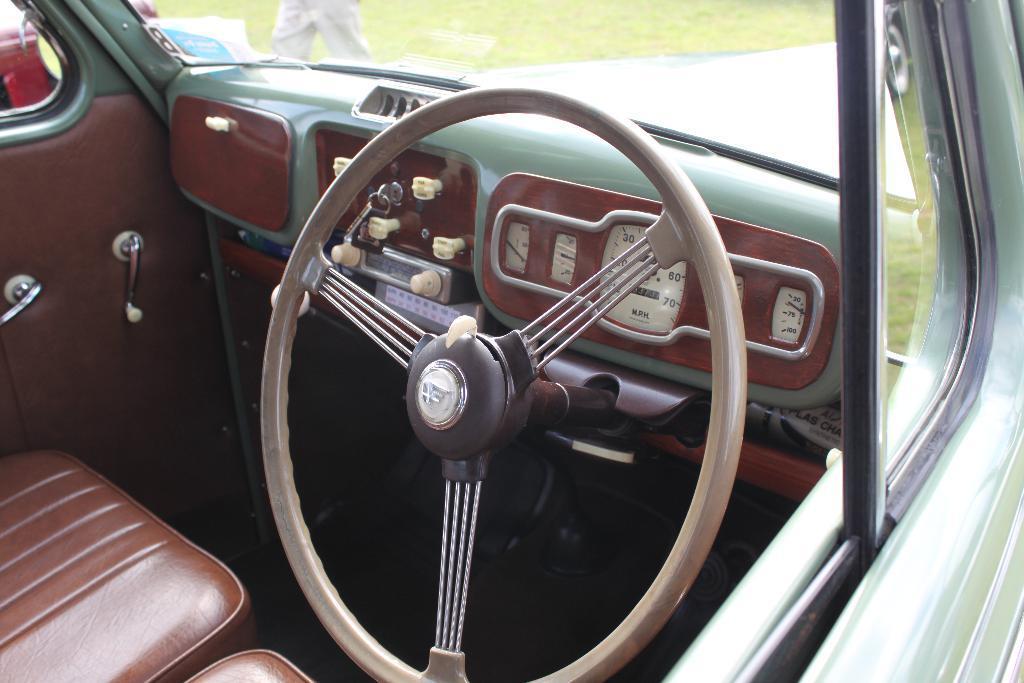Can you describe this image briefly? This picture is taken inside the vehicle. In the center, there is a steering. Beside the steering, there are seats. On the top, there is a glass. 